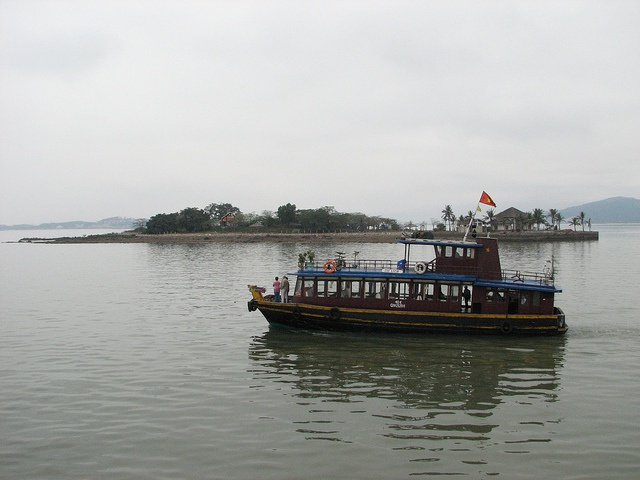Describe the objects in this image and their specific colors. I can see boat in lavender, black, gray, darkgray, and olive tones, people in lavender, gray, black, and darkgray tones, people in lavender, black, gray, brown, and purple tones, and people in lavender, black, gray, and darkgray tones in this image. 